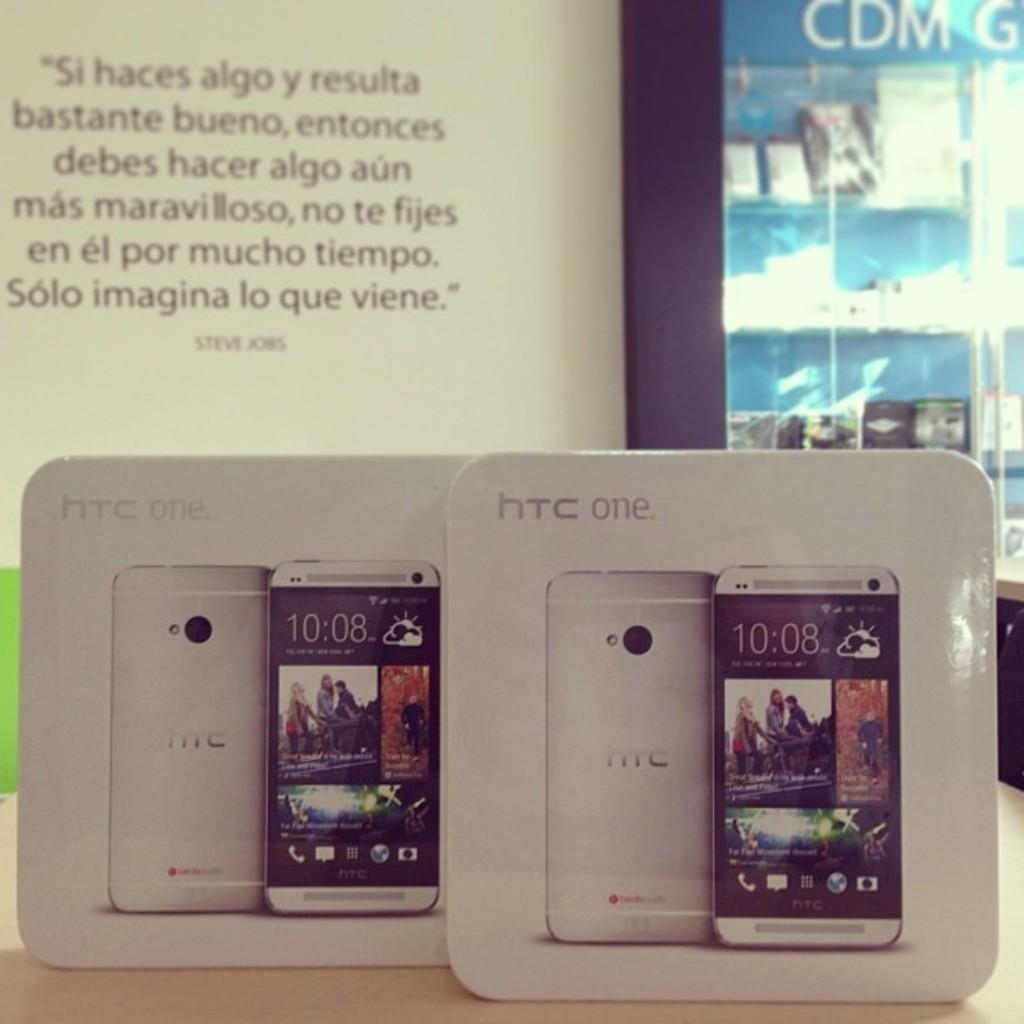<image>
Create a compact narrative representing the image presented. Two HTC ONE phones siting in front of a quote by Steve Jobs. 